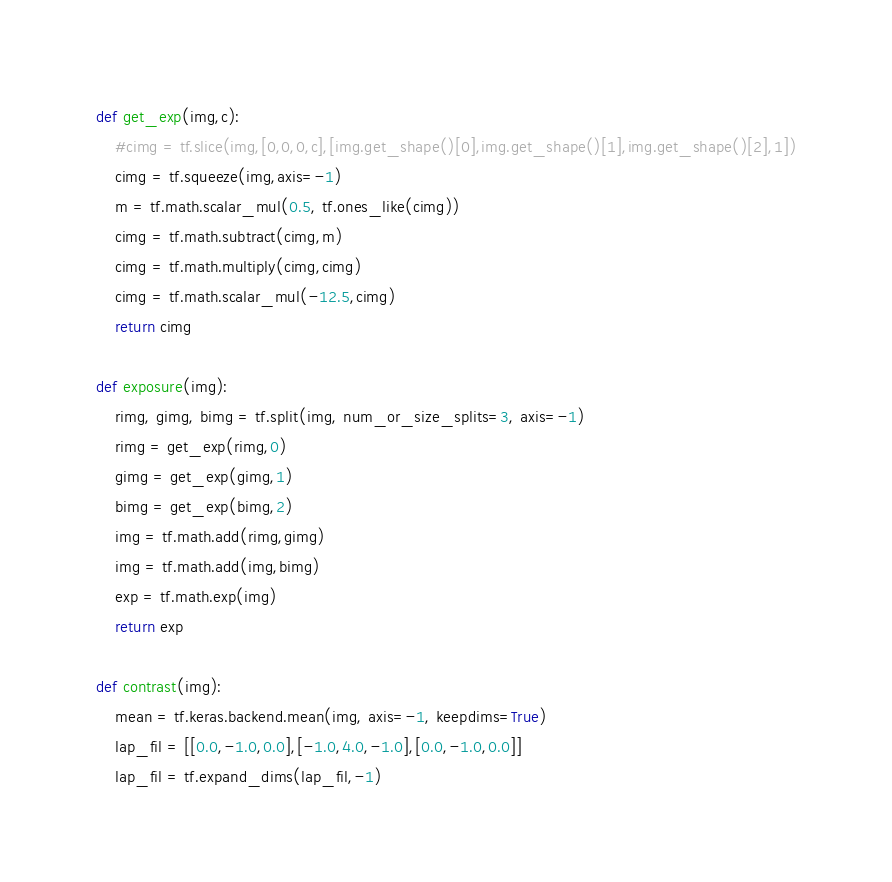<code> <loc_0><loc_0><loc_500><loc_500><_Python_>def get_exp(img,c):
	#cimg = tf.slice(img,[0,0,0,c],[img.get_shape()[0],img.get_shape()[1],img.get_shape()[2],1])
	cimg = tf.squeeze(img,axis=-1)
	m = tf.math.scalar_mul(0.5, tf.ones_like(cimg))
	cimg = tf.math.subtract(cimg,m)
	cimg = tf.math.multiply(cimg,cimg)
	cimg = tf.math.scalar_mul(-12.5,cimg)
	return cimg

def exposure(img):
	rimg, gimg, bimg = tf.split(img, num_or_size_splits=3, axis=-1)
	rimg = get_exp(rimg,0)
	gimg = get_exp(gimg,1)
	bimg = get_exp(bimg,2)
	img = tf.math.add(rimg,gimg)
	img = tf.math.add(img,bimg)
	exp = tf.math.exp(img)
	return exp

def contrast(img):
	mean = tf.keras.backend.mean(img, axis=-1, keepdims=True)
	lap_fil = [[0.0,-1.0,0.0],[-1.0,4.0,-1.0],[0.0,-1.0,0.0]]
	lap_fil = tf.expand_dims(lap_fil,-1)</code> 